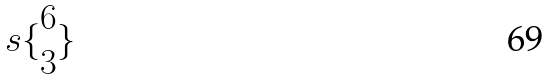<formula> <loc_0><loc_0><loc_500><loc_500>s \{ \begin{matrix} 6 \\ 3 \end{matrix} \}</formula> 